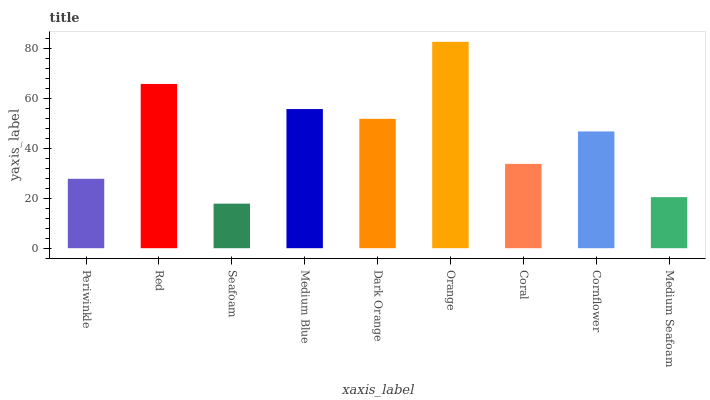Is Seafoam the minimum?
Answer yes or no. Yes. Is Orange the maximum?
Answer yes or no. Yes. Is Red the minimum?
Answer yes or no. No. Is Red the maximum?
Answer yes or no. No. Is Red greater than Periwinkle?
Answer yes or no. Yes. Is Periwinkle less than Red?
Answer yes or no. Yes. Is Periwinkle greater than Red?
Answer yes or no. No. Is Red less than Periwinkle?
Answer yes or no. No. Is Cornflower the high median?
Answer yes or no. Yes. Is Cornflower the low median?
Answer yes or no. Yes. Is Medium Seafoam the high median?
Answer yes or no. No. Is Dark Orange the low median?
Answer yes or no. No. 